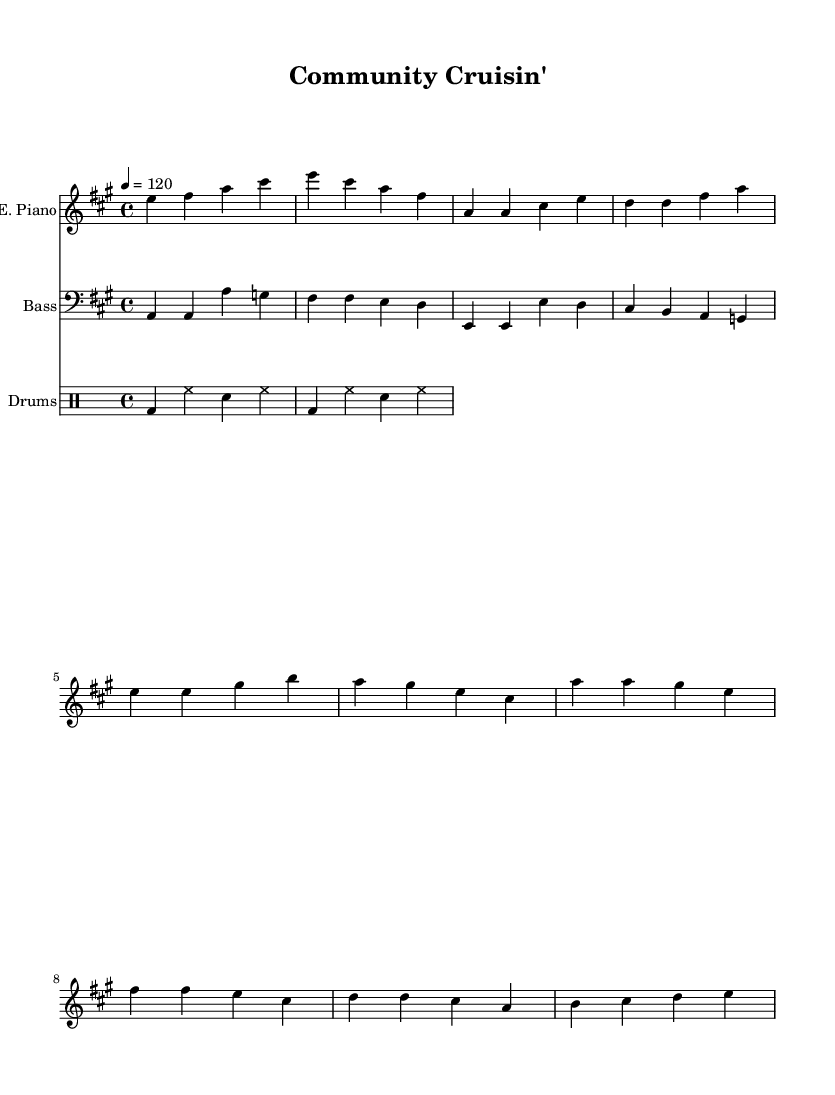What is the key signature of this music? The key signature is A major, which has three sharps: F#, C#, and G#.
Answer: A major What is the time signature of the piece? The time signature is indicated at the beginning of the sheet music with the symbol 4/4, which means there are four beats in each measure and the quarter note gets one beat.
Answer: 4/4 What is the tempo marking for this piece? The tempo marking shows a quarter note equals 120, indicating that there should be 120 beats per minute.
Answer: 120 How many measures are in the verse section? The verse consists of four measures as each segment is counted, and the measures contain distinct rhythmic patterns and notes.
Answer: 4 What instrument plays the main melody? The electric piano is designated as the primary instrument for playing the melody, as indicated in the staff labeled "E. Piano."
Answer: Electric Piano What drum pattern is used in the score? The drum pattern includes bass drums, hi-hat, and snare as per the typical disco genre patterns, providing a steady and danceable rhythm throughout the piece.
Answer: Bass, hi-hat, snare What is the structure of the song in terms of sections? The song is structured into an intro, verse, and chorus, with each section being indicated by the different segments of music present.
Answer: Intro, Verse, Chorus 